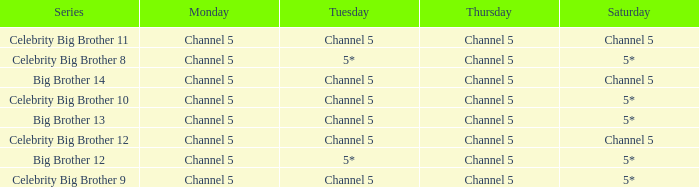Which series airs Saturday on Channel 5? Celebrity Big Brother 11, Big Brother 14, Celebrity Big Brother 12. 